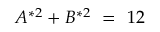Convert formula to latex. <formula><loc_0><loc_0><loc_500><loc_500>A ^ { * 2 } + B ^ { * 2 } \ = \ 1 2</formula> 